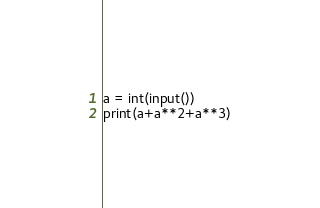Convert code to text. <code><loc_0><loc_0><loc_500><loc_500><_Python_>a = int(input())
print(a+a**2+a**3)</code> 